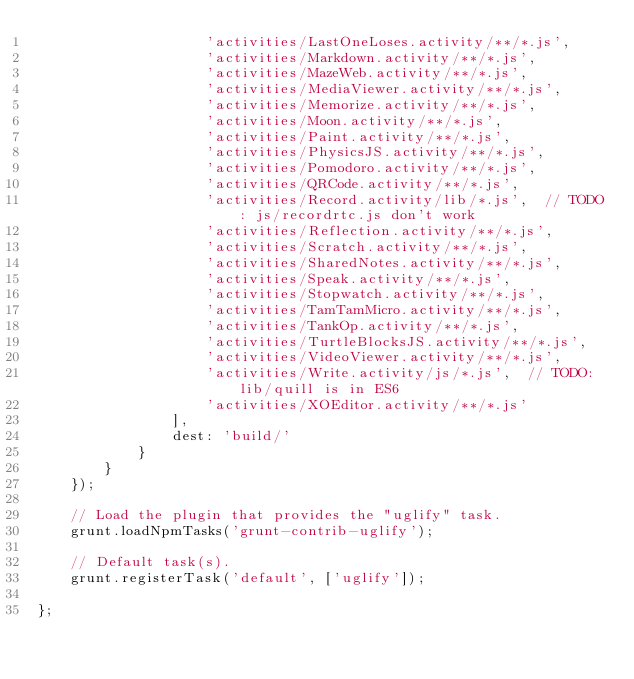<code> <loc_0><loc_0><loc_500><loc_500><_JavaScript_>					'activities/LastOneLoses.activity/**/*.js',
					'activities/Markdown.activity/**/*.js',
					'activities/MazeWeb.activity/**/*.js',
					'activities/MediaViewer.activity/**/*.js',
					'activities/Memorize.activity/**/*.js',
					'activities/Moon.activity/**/*.js',
					'activities/Paint.activity/**/*.js',
					'activities/PhysicsJS.activity/**/*.js',
					'activities/Pomodoro.activity/**/*.js',
					'activities/QRCode.activity/**/*.js',
					'activities/Record.activity/lib/*.js',  // TODO: js/recordrtc.js don't work
					'activities/Reflection.activity/**/*.js',
					'activities/Scratch.activity/**/*.js',
					'activities/SharedNotes.activity/**/*.js',
					'activities/Speak.activity/**/*.js',
					'activities/Stopwatch.activity/**/*.js',
					'activities/TamTamMicro.activity/**/*.js',
					'activities/TankOp.activity/**/*.js',
					'activities/TurtleBlocksJS.activity/**/*.js',
					'activities/VideoViewer.activity/**/*.js',
					'activities/Write.activity/js/*.js',  // TODO: lib/quill is in ES6
					'activities/XOEditor.activity/**/*.js'
				],
				dest: 'build/'
			}
		}
	});

	// Load the plugin that provides the "uglify" task.
	grunt.loadNpmTasks('grunt-contrib-uglify');

	// Default task(s).
	grunt.registerTask('default', ['uglify']);

};
</code> 